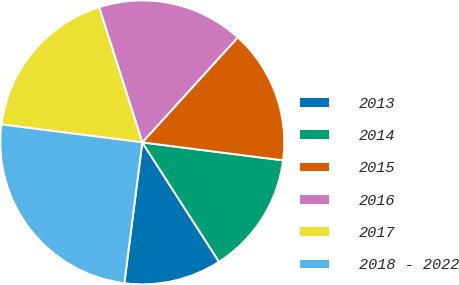<chart> <loc_0><loc_0><loc_500><loc_500><pie_chart><fcel>2013<fcel>2014<fcel>2015<fcel>2016<fcel>2017<fcel>2018 - 2022<nl><fcel>11.11%<fcel>13.89%<fcel>15.28%<fcel>16.67%<fcel>18.06%<fcel>25.0%<nl></chart> 